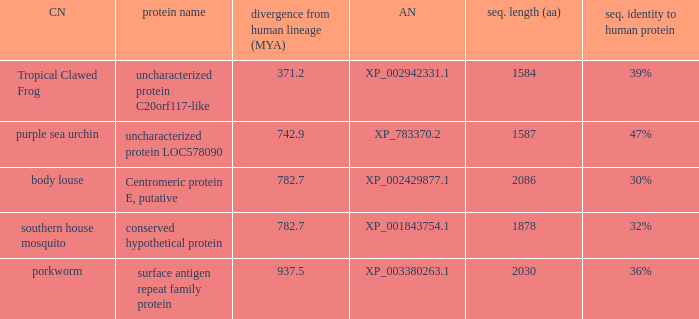What is the protein name of the protein with a sequence identity to human protein of 32%? Conserved hypothetical protein. 